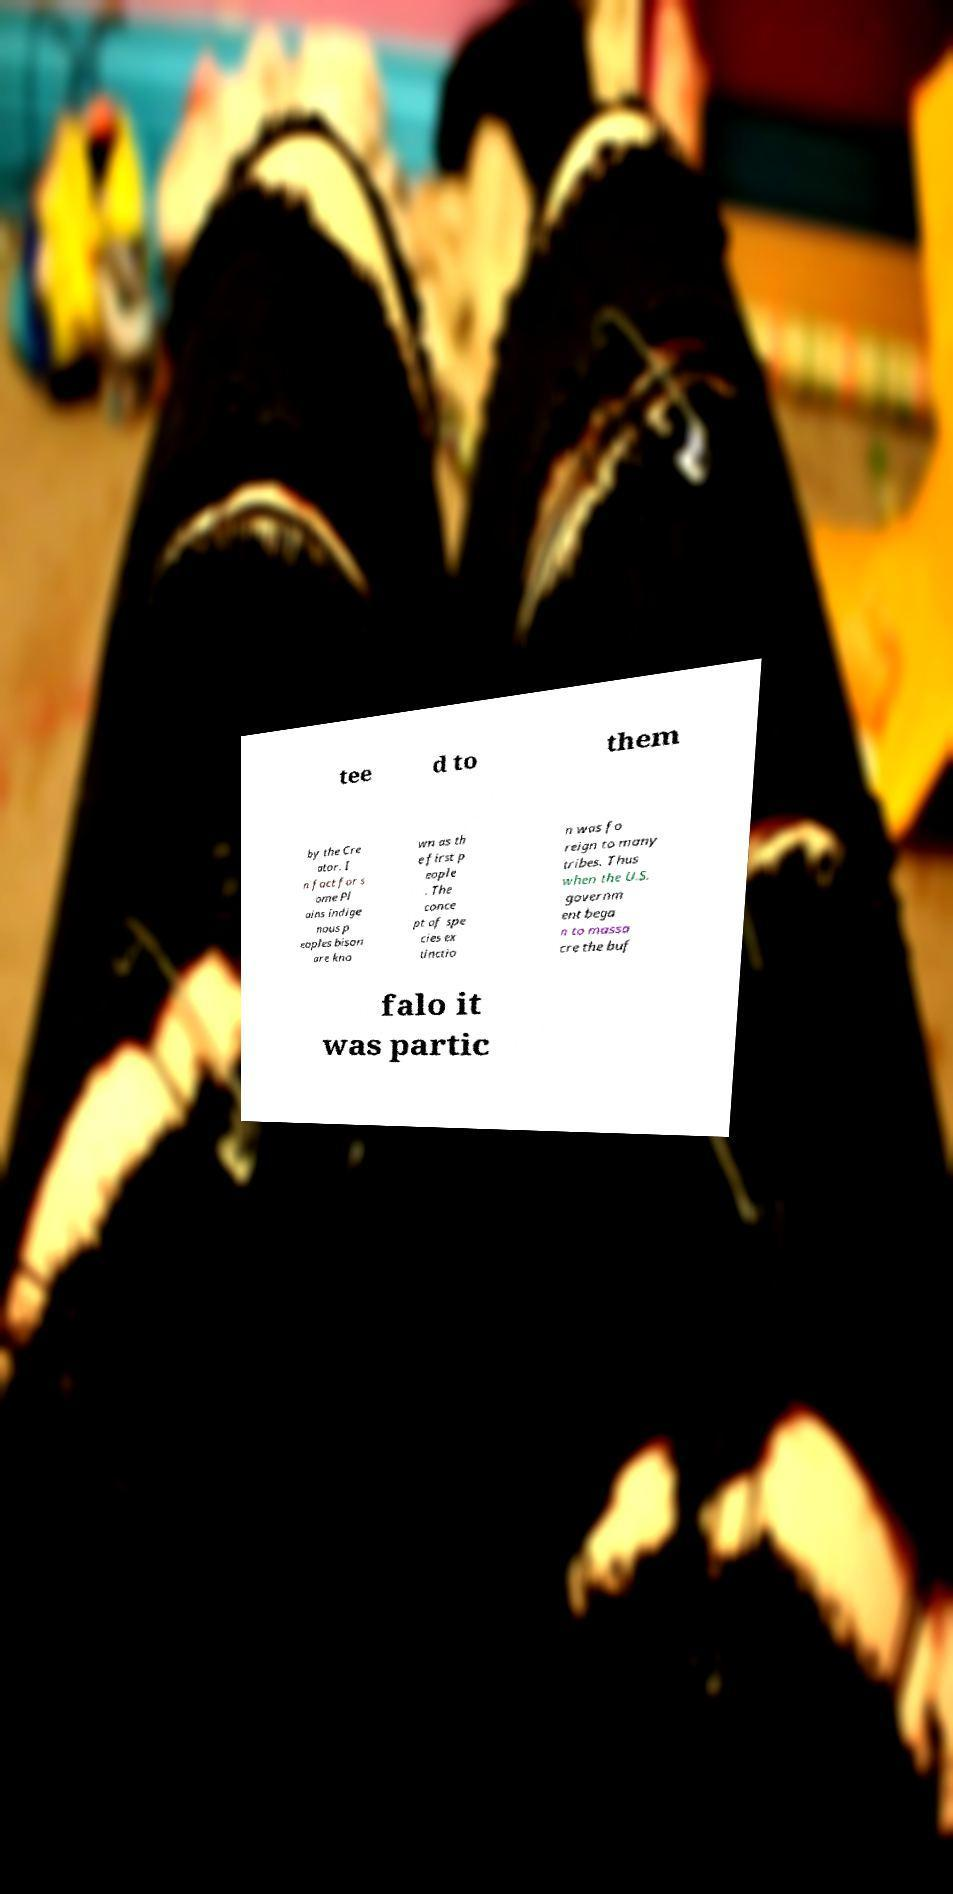Can you read and provide the text displayed in the image?This photo seems to have some interesting text. Can you extract and type it out for me? tee d to them by the Cre ator. I n fact for s ome Pl ains indige nous p eoples bison are kno wn as th e first p eople . The conce pt of spe cies ex tinctio n was fo reign to many tribes. Thus when the U.S. governm ent bega n to massa cre the buf falo it was partic 